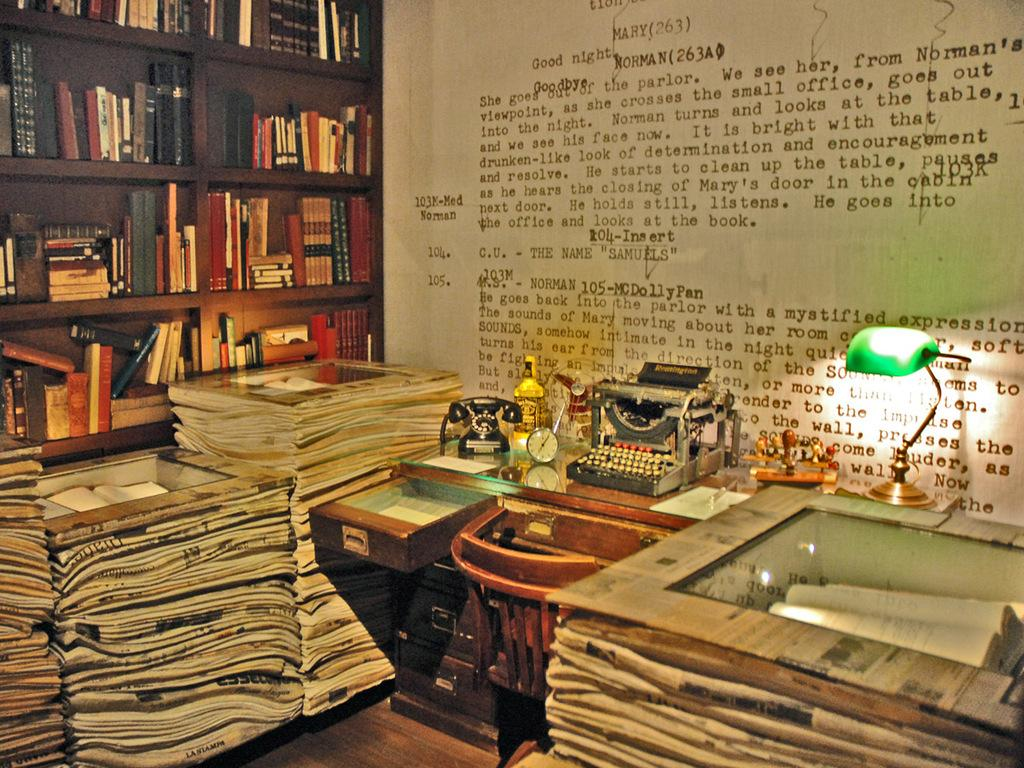<image>
Present a compact description of the photo's key features. A museum exhibit showing papers, books and an ornate typwriter in front of a wall of text which is an excerpt from a play. 